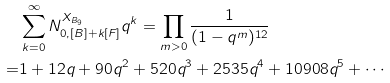<formula> <loc_0><loc_0><loc_500><loc_500>& \sum _ { k = 0 } ^ { \infty } N _ { 0 , [ B ] + k [ F ] } ^ { X _ { B _ { 9 } } } q ^ { k } = \prod _ { m > 0 } \frac { 1 } { ( 1 - q ^ { m } ) ^ { 1 2 } } \\ = & 1 + 1 2 q + 9 0 q ^ { 2 } + 5 2 0 q ^ { 3 } + 2 5 3 5 q ^ { 4 } + 1 0 9 0 8 q ^ { 5 } + \cdots</formula> 